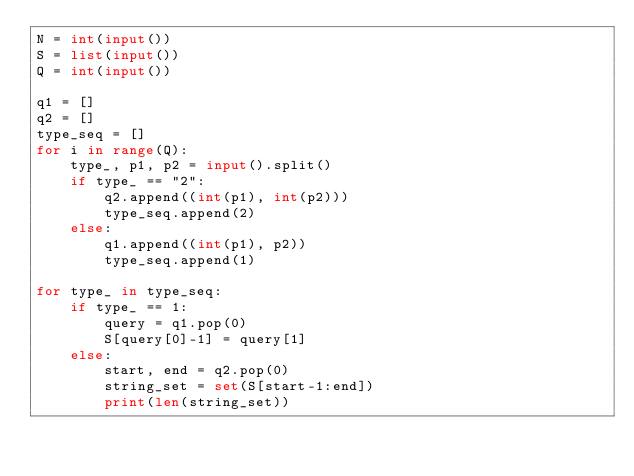Convert code to text. <code><loc_0><loc_0><loc_500><loc_500><_Python_>N = int(input())
S = list(input())
Q = int(input())

q1 = []
q2 = []
type_seq = []
for i in range(Q):
    type_, p1, p2 = input().split()
    if type_ == "2":
        q2.append((int(p1), int(p2)))
        type_seq.append(2)
    else:
        q1.append((int(p1), p2))
        type_seq.append(1)

for type_ in type_seq:
    if type_ == 1:
        query = q1.pop(0)
        S[query[0]-1] = query[1]
    else:
        start, end = q2.pop(0)
        string_set = set(S[start-1:end])
        print(len(string_set))



</code> 